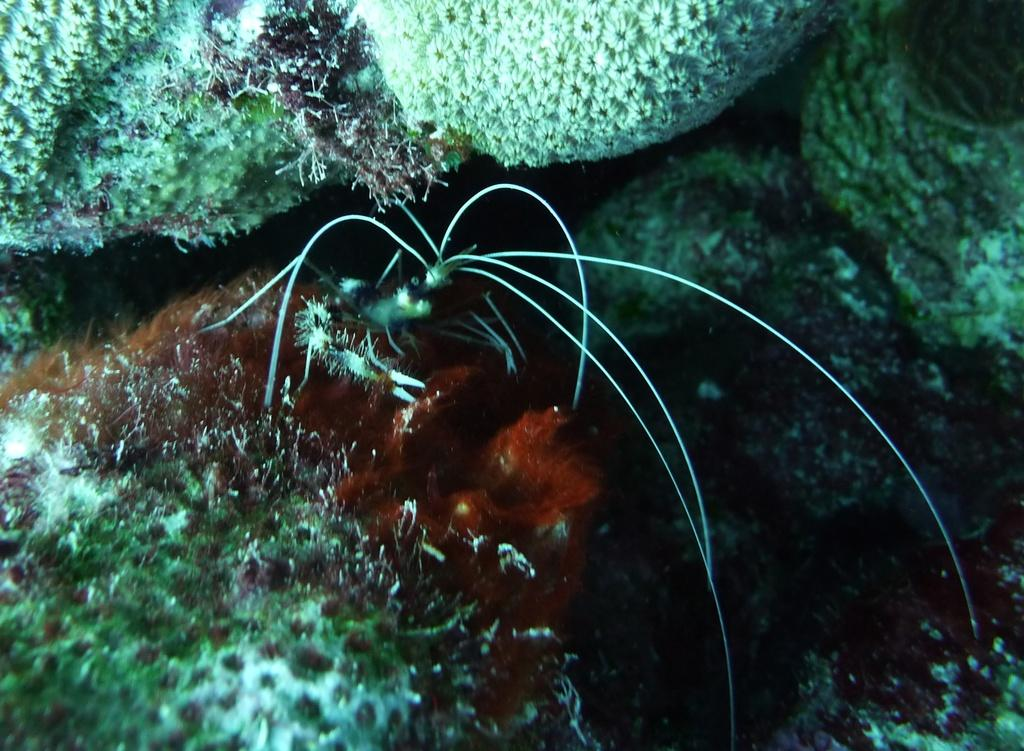What is the main subject in the middle of the image? There is an insect in the middle of the image. What type of vegetation can be seen in the background of the image? There are water plants in the background of the image. What type of drink is the insect holding in the image? There is no drink present in the image, as it features an insect and water plants. Can you see any coal in the image? There is no coal present in the image. 